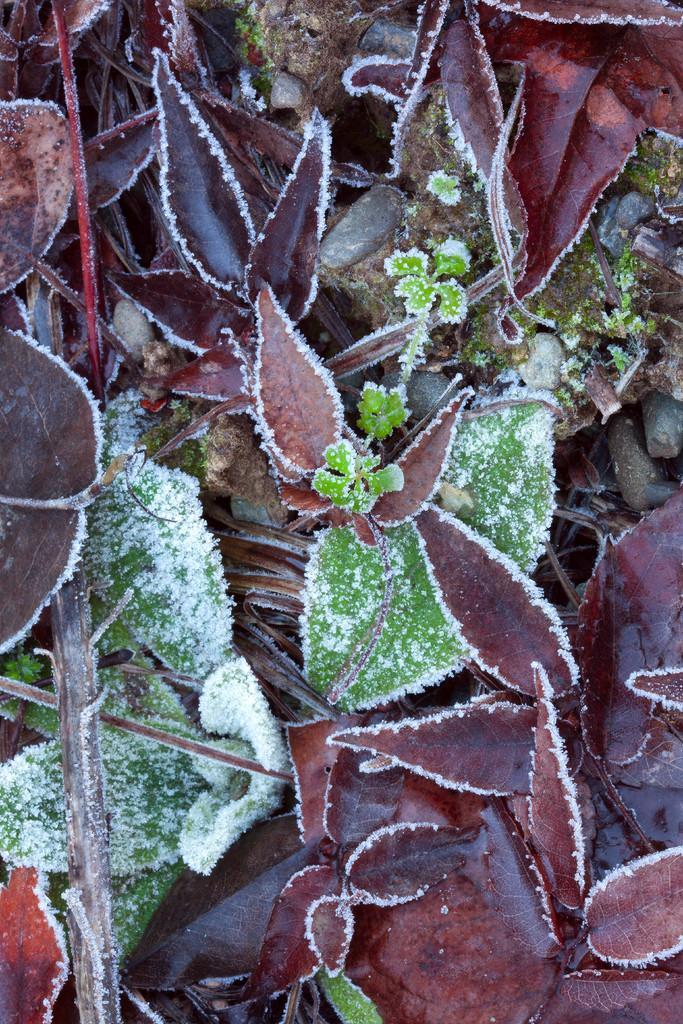Please provide a concise description of this image. In this image we can see leaves covered by snow. 